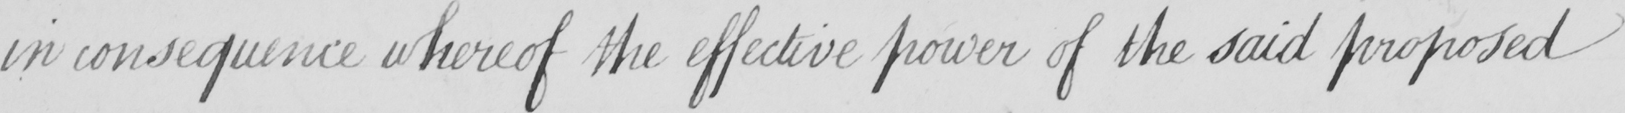Please provide the text content of this handwritten line. in consequence whereof the effective power of the said proposed 